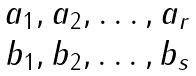Convert formula to latex. <formula><loc_0><loc_0><loc_500><loc_500>\begin{matrix} { a _ { 1 } , a _ { 2 } , \dots , a _ { r } } \\ { b _ { 1 } , b _ { 2 } , \dots , b _ { s } } \end{matrix}</formula> 